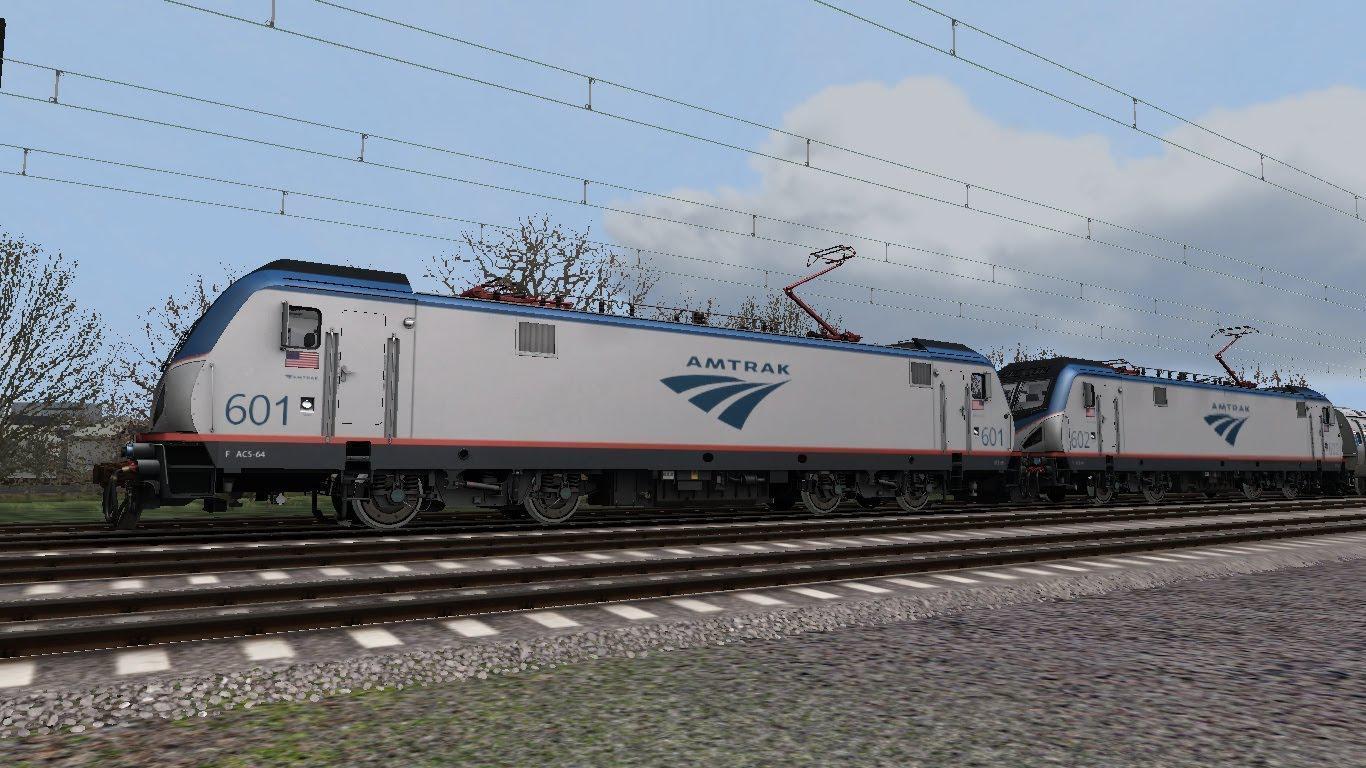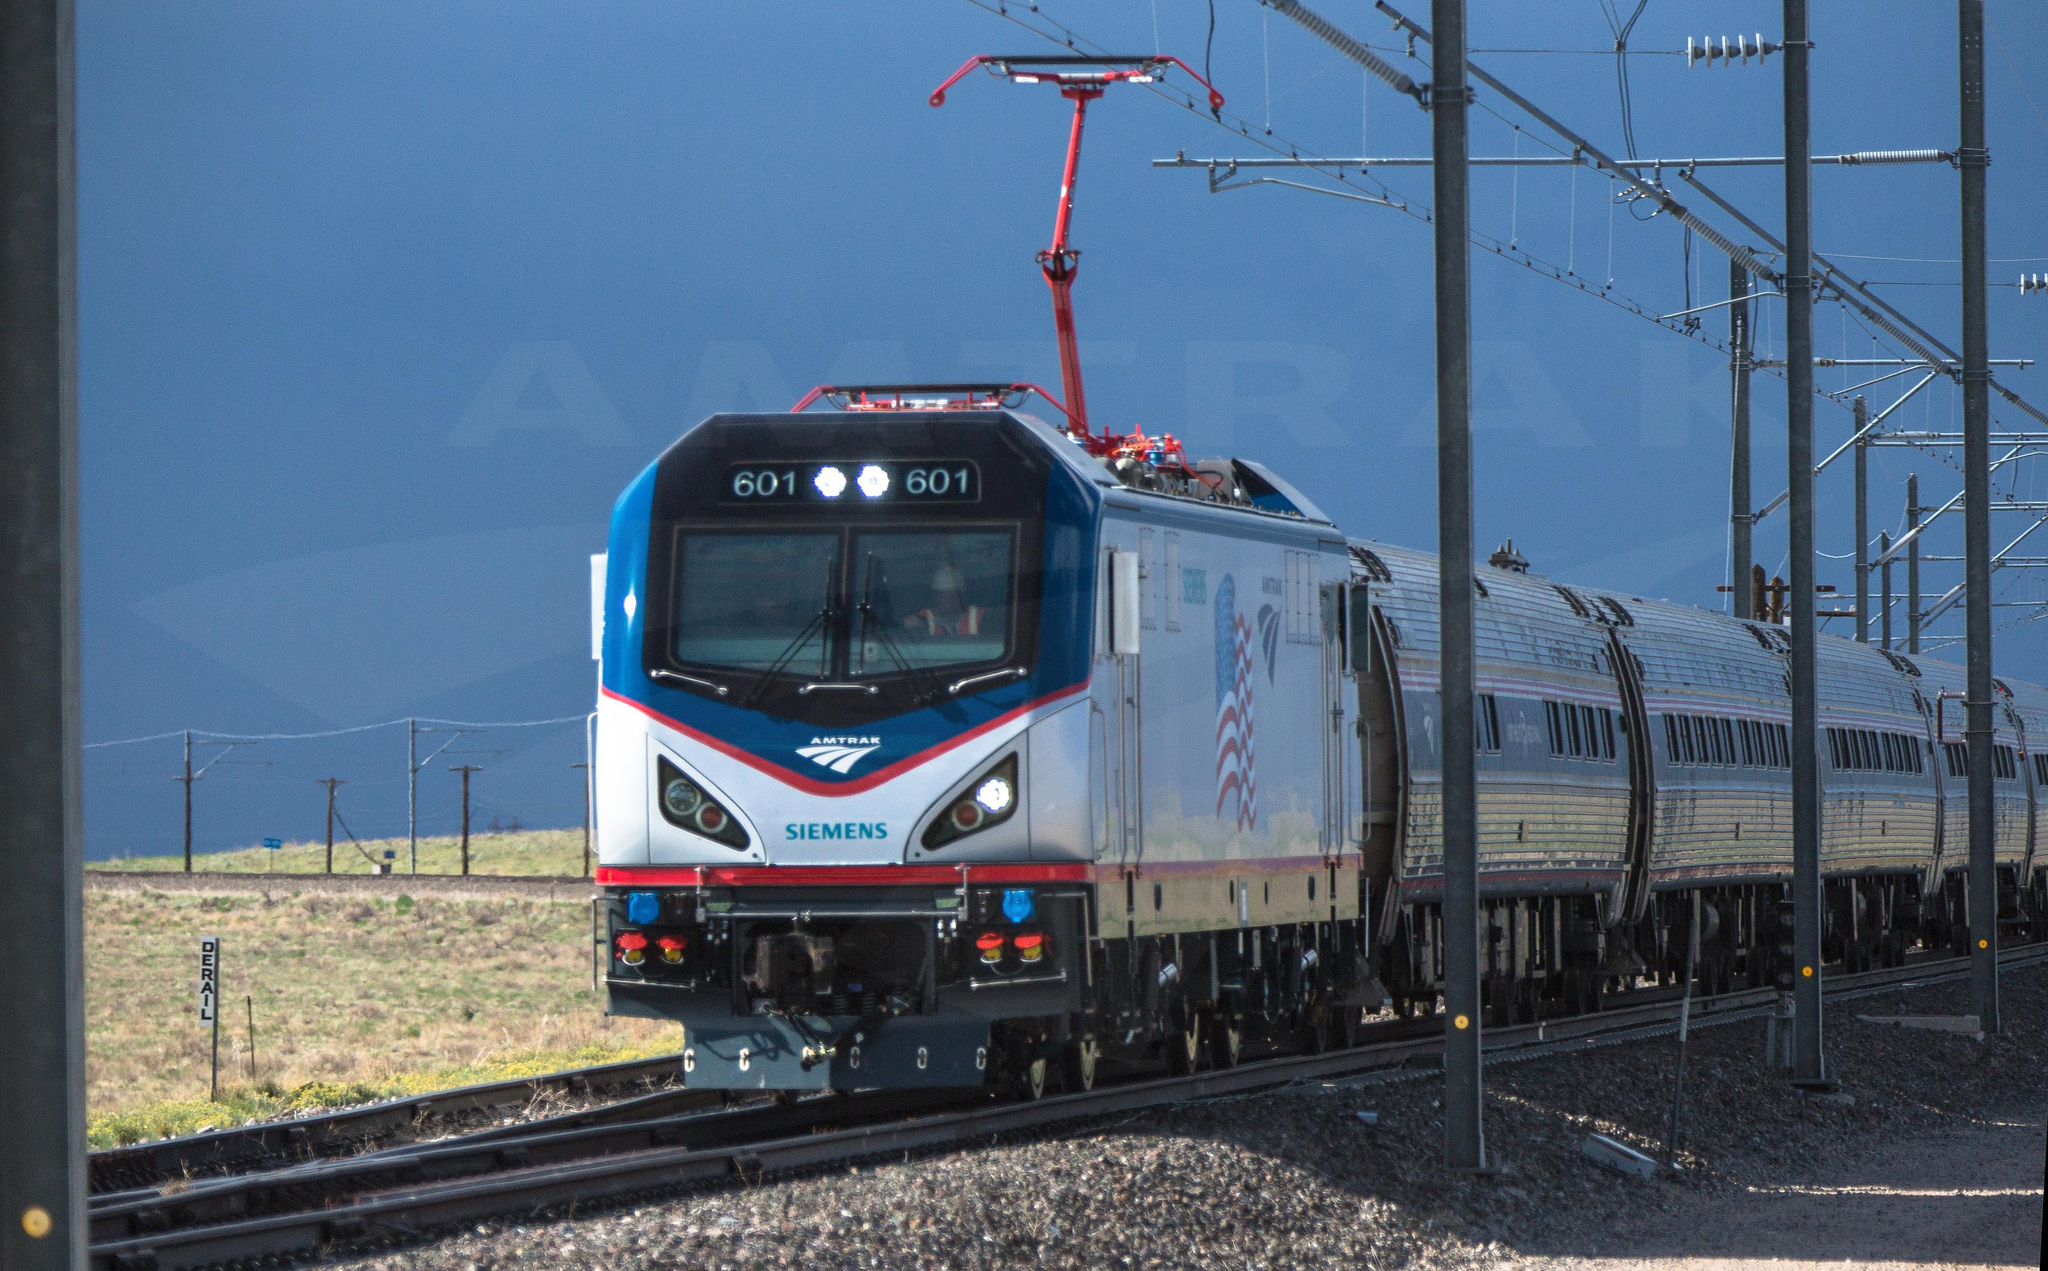The first image is the image on the left, the second image is the image on the right. Considering the images on both sides, is "There are at least six power poles in the image on the right." valid? Answer yes or no. Yes. 